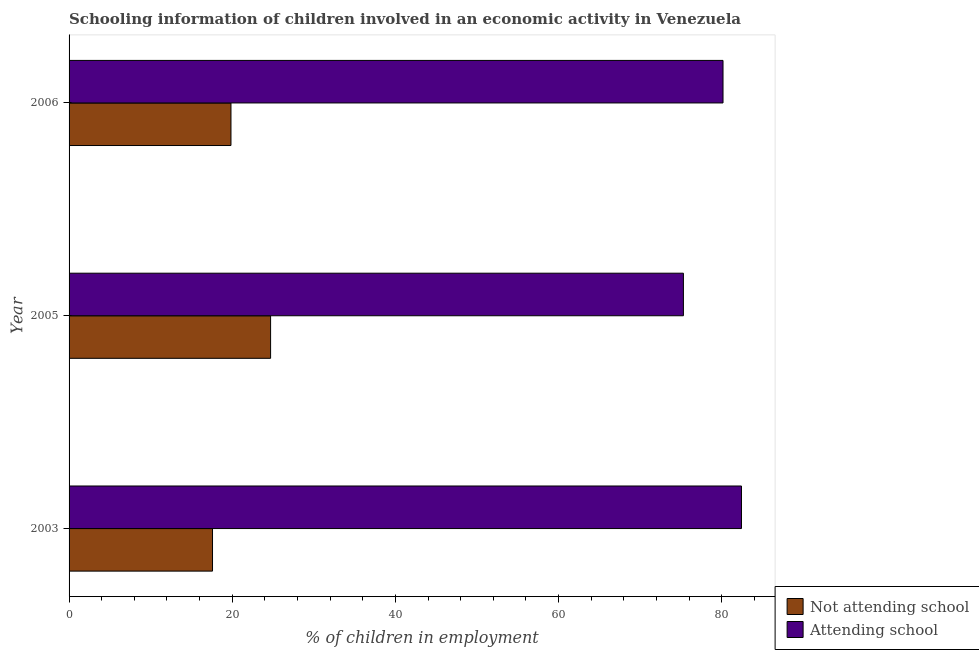How many different coloured bars are there?
Provide a short and direct response. 2. Are the number of bars on each tick of the Y-axis equal?
Offer a terse response. Yes. How many bars are there on the 3rd tick from the top?
Provide a succinct answer. 2. In how many cases, is the number of bars for a given year not equal to the number of legend labels?
Give a very brief answer. 0. What is the percentage of employed children who are not attending school in 2006?
Provide a short and direct response. 19.84. Across all years, what is the maximum percentage of employed children who are attending school?
Keep it short and to the point. 82.42. Across all years, what is the minimum percentage of employed children who are attending school?
Keep it short and to the point. 75.3. In which year was the percentage of employed children who are attending school maximum?
Offer a terse response. 2003. In which year was the percentage of employed children who are attending school minimum?
Your answer should be very brief. 2005. What is the total percentage of employed children who are attending school in the graph?
Make the answer very short. 237.87. What is the difference between the percentage of employed children who are attending school in 2003 and that in 2005?
Provide a short and direct response. 7.12. What is the difference between the percentage of employed children who are not attending school in 2006 and the percentage of employed children who are attending school in 2005?
Offer a terse response. -55.46. What is the average percentage of employed children who are not attending school per year?
Your response must be concise. 20.71. In the year 2003, what is the difference between the percentage of employed children who are not attending school and percentage of employed children who are attending school?
Offer a very short reply. -64.83. In how many years, is the percentage of employed children who are not attending school greater than 12 %?
Provide a short and direct response. 3. What is the ratio of the percentage of employed children who are attending school in 2003 to that in 2005?
Make the answer very short. 1.09. Is the difference between the percentage of employed children who are not attending school in 2003 and 2005 greater than the difference between the percentage of employed children who are attending school in 2003 and 2005?
Offer a terse response. No. What is the difference between the highest and the second highest percentage of employed children who are not attending school?
Provide a short and direct response. 4.86. What is the difference between the highest and the lowest percentage of employed children who are not attending school?
Offer a very short reply. 7.12. What does the 1st bar from the top in 2003 represents?
Provide a short and direct response. Attending school. What does the 2nd bar from the bottom in 2005 represents?
Your response must be concise. Attending school. How many bars are there?
Keep it short and to the point. 6. Are all the bars in the graph horizontal?
Provide a succinct answer. Yes. How many years are there in the graph?
Your response must be concise. 3. What is the difference between two consecutive major ticks on the X-axis?
Your answer should be very brief. 20. Are the values on the major ticks of X-axis written in scientific E-notation?
Your answer should be compact. No. Does the graph contain any zero values?
Provide a succinct answer. No. How many legend labels are there?
Your answer should be very brief. 2. What is the title of the graph?
Your answer should be very brief. Schooling information of children involved in an economic activity in Venezuela. Does "International Tourists" appear as one of the legend labels in the graph?
Make the answer very short. No. What is the label or title of the X-axis?
Offer a very short reply. % of children in employment. What is the label or title of the Y-axis?
Make the answer very short. Year. What is the % of children in employment of Not attending school in 2003?
Ensure brevity in your answer.  17.58. What is the % of children in employment in Attending school in 2003?
Offer a very short reply. 82.42. What is the % of children in employment of Not attending school in 2005?
Give a very brief answer. 24.7. What is the % of children in employment of Attending school in 2005?
Offer a terse response. 75.3. What is the % of children in employment of Not attending school in 2006?
Offer a very short reply. 19.84. What is the % of children in employment of Attending school in 2006?
Offer a very short reply. 80.16. Across all years, what is the maximum % of children in employment in Not attending school?
Your answer should be very brief. 24.7. Across all years, what is the maximum % of children in employment in Attending school?
Make the answer very short. 82.42. Across all years, what is the minimum % of children in employment in Not attending school?
Provide a short and direct response. 17.58. Across all years, what is the minimum % of children in employment of Attending school?
Keep it short and to the point. 75.3. What is the total % of children in employment in Not attending school in the graph?
Give a very brief answer. 62.13. What is the total % of children in employment of Attending school in the graph?
Your answer should be compact. 237.87. What is the difference between the % of children in employment of Not attending school in 2003 and that in 2005?
Offer a terse response. -7.12. What is the difference between the % of children in employment of Attending school in 2003 and that in 2005?
Your answer should be very brief. 7.12. What is the difference between the % of children in employment of Not attending school in 2003 and that in 2006?
Make the answer very short. -2.26. What is the difference between the % of children in employment in Attending school in 2003 and that in 2006?
Your answer should be very brief. 2.26. What is the difference between the % of children in employment of Not attending school in 2005 and that in 2006?
Offer a terse response. 4.86. What is the difference between the % of children in employment of Attending school in 2005 and that in 2006?
Keep it short and to the point. -4.86. What is the difference between the % of children in employment in Not attending school in 2003 and the % of children in employment in Attending school in 2005?
Offer a very short reply. -57.72. What is the difference between the % of children in employment in Not attending school in 2003 and the % of children in employment in Attending school in 2006?
Ensure brevity in your answer.  -62.57. What is the difference between the % of children in employment of Not attending school in 2005 and the % of children in employment of Attending school in 2006?
Keep it short and to the point. -55.46. What is the average % of children in employment in Not attending school per year?
Provide a short and direct response. 20.71. What is the average % of children in employment in Attending school per year?
Your answer should be very brief. 79.29. In the year 2003, what is the difference between the % of children in employment of Not attending school and % of children in employment of Attending school?
Your response must be concise. -64.84. In the year 2005, what is the difference between the % of children in employment of Not attending school and % of children in employment of Attending school?
Your answer should be very brief. -50.6. In the year 2006, what is the difference between the % of children in employment in Not attending school and % of children in employment in Attending school?
Keep it short and to the point. -60.31. What is the ratio of the % of children in employment of Not attending school in 2003 to that in 2005?
Your response must be concise. 0.71. What is the ratio of the % of children in employment of Attending school in 2003 to that in 2005?
Offer a terse response. 1.09. What is the ratio of the % of children in employment of Not attending school in 2003 to that in 2006?
Give a very brief answer. 0.89. What is the ratio of the % of children in employment in Attending school in 2003 to that in 2006?
Your response must be concise. 1.03. What is the ratio of the % of children in employment of Not attending school in 2005 to that in 2006?
Offer a very short reply. 1.24. What is the ratio of the % of children in employment in Attending school in 2005 to that in 2006?
Offer a terse response. 0.94. What is the difference between the highest and the second highest % of children in employment of Not attending school?
Your response must be concise. 4.86. What is the difference between the highest and the second highest % of children in employment in Attending school?
Make the answer very short. 2.26. What is the difference between the highest and the lowest % of children in employment in Not attending school?
Keep it short and to the point. 7.12. What is the difference between the highest and the lowest % of children in employment of Attending school?
Keep it short and to the point. 7.12. 